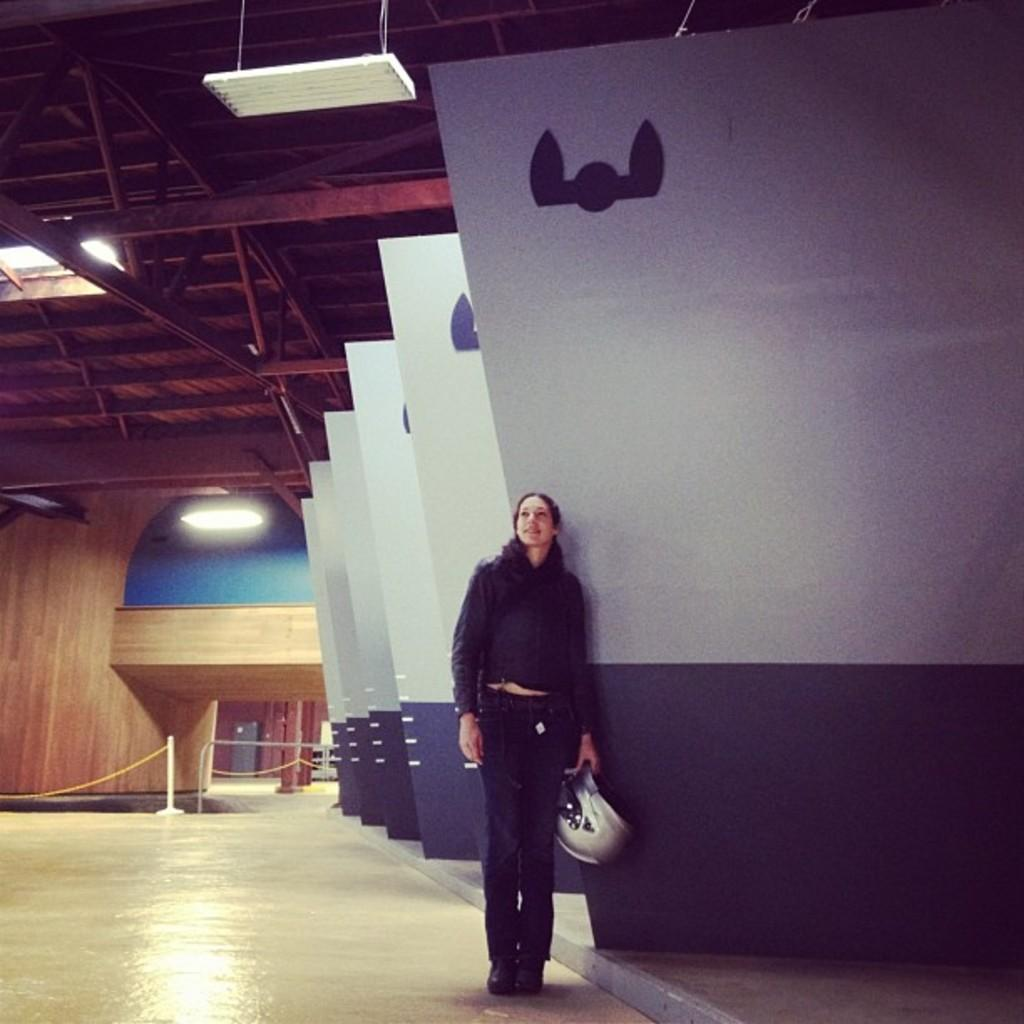What is the main subject of the image? There is a woman in the image. What is the woman doing in the image? The woman is standing in the image. What object is the woman holding in the image? The woman is holding a helmet in the image. What is the woman wearing in the image? The woman is wearing a black dress in the image. What can be seen in the background of the image? Boards and a wooden wall are visible in the background of the image. What is the source of light in the image? There is a light visible at the top of the image. Can you see a snake slithering on the wooden wall in the image? There is no snake present in the image; only the woman, the helmet, the black dress, the boards, the wooden wall, and the light are visible. 